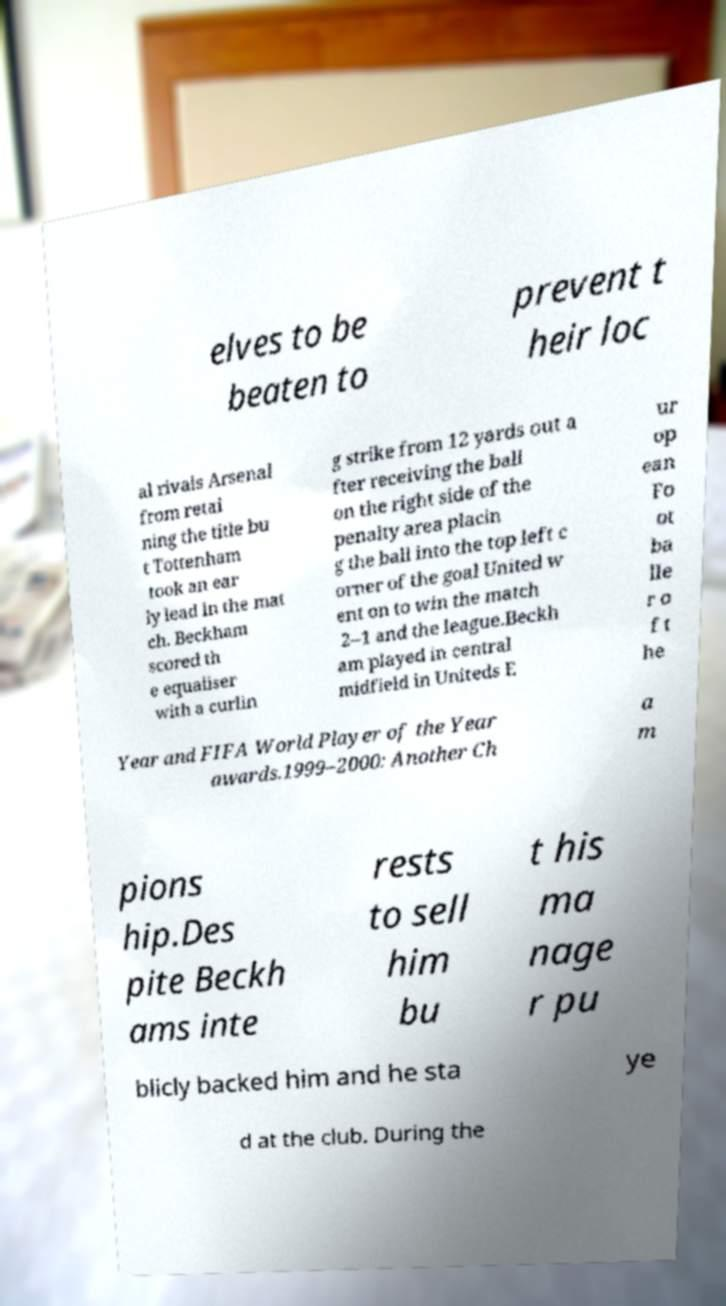Please read and relay the text visible in this image. What does it say? elves to be beaten to prevent t heir loc al rivals Arsenal from retai ning the title bu t Tottenham took an ear ly lead in the mat ch. Beckham scored th e equaliser with a curlin g strike from 12 yards out a fter receiving the ball on the right side of the penalty area placin g the ball into the top left c orner of the goal United w ent on to win the match 2–1 and the league.Beckh am played in central midfield in Uniteds E ur op ean Fo ot ba lle r o f t he Year and FIFA World Player of the Year awards.1999–2000: Another Ch a m pions hip.Des pite Beckh ams inte rests to sell him bu t his ma nage r pu blicly backed him and he sta ye d at the club. During the 